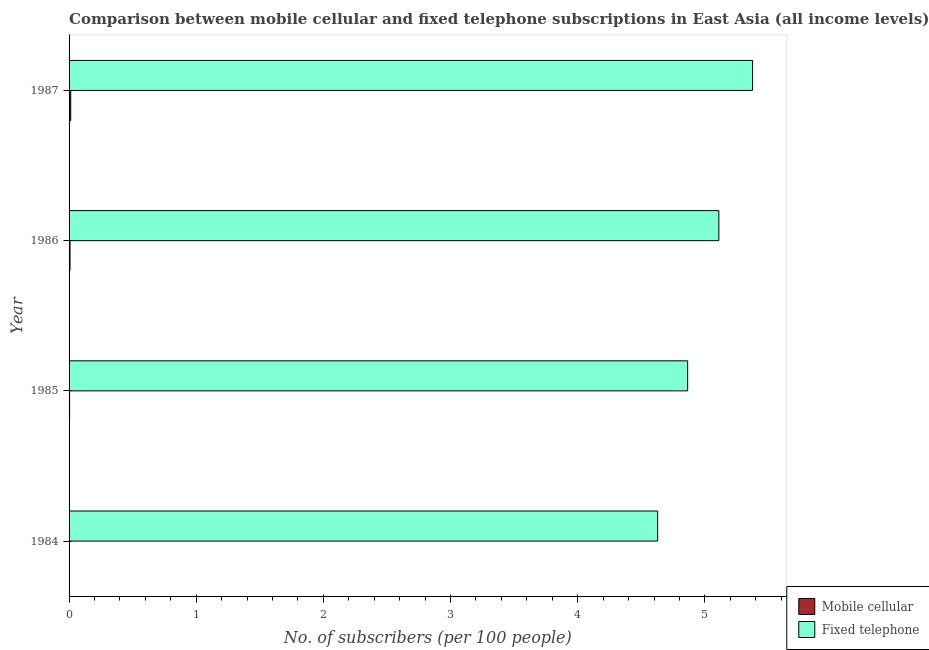How many groups of bars are there?
Offer a very short reply. 4. Are the number of bars per tick equal to the number of legend labels?
Make the answer very short. Yes. Are the number of bars on each tick of the Y-axis equal?
Give a very brief answer. Yes. How many bars are there on the 2nd tick from the top?
Keep it short and to the point. 2. How many bars are there on the 4th tick from the bottom?
Offer a terse response. 2. What is the label of the 3rd group of bars from the top?
Provide a succinct answer. 1985. What is the number of fixed telephone subscribers in 1984?
Make the answer very short. 4.63. Across all years, what is the maximum number of mobile cellular subscribers?
Provide a succinct answer. 0.01. Across all years, what is the minimum number of mobile cellular subscribers?
Your response must be concise. 0. In which year was the number of fixed telephone subscribers maximum?
Provide a succinct answer. 1987. In which year was the number of fixed telephone subscribers minimum?
Your answer should be very brief. 1984. What is the total number of fixed telephone subscribers in the graph?
Offer a very short reply. 19.98. What is the difference between the number of mobile cellular subscribers in 1985 and that in 1987?
Your response must be concise. -0.01. What is the difference between the number of fixed telephone subscribers in 1984 and the number of mobile cellular subscribers in 1987?
Provide a succinct answer. 4.62. What is the average number of mobile cellular subscribers per year?
Give a very brief answer. 0.01. In the year 1984, what is the difference between the number of mobile cellular subscribers and number of fixed telephone subscribers?
Keep it short and to the point. -4.63. What is the ratio of the number of fixed telephone subscribers in 1985 to that in 1987?
Provide a succinct answer. 0.91. What is the difference between the highest and the second highest number of mobile cellular subscribers?
Provide a short and direct response. 0.01. In how many years, is the number of mobile cellular subscribers greater than the average number of mobile cellular subscribers taken over all years?
Keep it short and to the point. 2. Is the sum of the number of fixed telephone subscribers in 1984 and 1985 greater than the maximum number of mobile cellular subscribers across all years?
Offer a terse response. Yes. What does the 1st bar from the top in 1987 represents?
Give a very brief answer. Fixed telephone. What does the 1st bar from the bottom in 1984 represents?
Your answer should be compact. Mobile cellular. How many bars are there?
Your response must be concise. 8. How many years are there in the graph?
Give a very brief answer. 4. What is the difference between two consecutive major ticks on the X-axis?
Provide a short and direct response. 1. Does the graph contain any zero values?
Your response must be concise. No. What is the title of the graph?
Provide a short and direct response. Comparison between mobile cellular and fixed telephone subscriptions in East Asia (all income levels). What is the label or title of the X-axis?
Your answer should be very brief. No. of subscribers (per 100 people). What is the No. of subscribers (per 100 people) of Mobile cellular in 1984?
Make the answer very short. 0. What is the No. of subscribers (per 100 people) of Fixed telephone in 1984?
Give a very brief answer. 4.63. What is the No. of subscribers (per 100 people) in Mobile cellular in 1985?
Keep it short and to the point. 0. What is the No. of subscribers (per 100 people) in Fixed telephone in 1985?
Your answer should be very brief. 4.86. What is the No. of subscribers (per 100 people) in Mobile cellular in 1986?
Your answer should be very brief. 0.01. What is the No. of subscribers (per 100 people) in Fixed telephone in 1986?
Ensure brevity in your answer.  5.11. What is the No. of subscribers (per 100 people) of Mobile cellular in 1987?
Give a very brief answer. 0.01. What is the No. of subscribers (per 100 people) in Fixed telephone in 1987?
Provide a short and direct response. 5.38. Across all years, what is the maximum No. of subscribers (per 100 people) in Mobile cellular?
Your answer should be compact. 0.01. Across all years, what is the maximum No. of subscribers (per 100 people) in Fixed telephone?
Give a very brief answer. 5.38. Across all years, what is the minimum No. of subscribers (per 100 people) in Mobile cellular?
Your answer should be very brief. 0. Across all years, what is the minimum No. of subscribers (per 100 people) in Fixed telephone?
Provide a succinct answer. 4.63. What is the total No. of subscribers (per 100 people) of Mobile cellular in the graph?
Make the answer very short. 0.03. What is the total No. of subscribers (per 100 people) of Fixed telephone in the graph?
Your answer should be compact. 19.98. What is the difference between the No. of subscribers (per 100 people) of Mobile cellular in 1984 and that in 1985?
Provide a succinct answer. -0. What is the difference between the No. of subscribers (per 100 people) of Fixed telephone in 1984 and that in 1985?
Make the answer very short. -0.24. What is the difference between the No. of subscribers (per 100 people) of Mobile cellular in 1984 and that in 1986?
Give a very brief answer. -0. What is the difference between the No. of subscribers (per 100 people) in Fixed telephone in 1984 and that in 1986?
Ensure brevity in your answer.  -0.48. What is the difference between the No. of subscribers (per 100 people) of Mobile cellular in 1984 and that in 1987?
Keep it short and to the point. -0.01. What is the difference between the No. of subscribers (per 100 people) in Fixed telephone in 1984 and that in 1987?
Offer a very short reply. -0.75. What is the difference between the No. of subscribers (per 100 people) of Mobile cellular in 1985 and that in 1986?
Ensure brevity in your answer.  -0. What is the difference between the No. of subscribers (per 100 people) in Fixed telephone in 1985 and that in 1986?
Give a very brief answer. -0.25. What is the difference between the No. of subscribers (per 100 people) in Mobile cellular in 1985 and that in 1987?
Your response must be concise. -0.01. What is the difference between the No. of subscribers (per 100 people) of Fixed telephone in 1985 and that in 1987?
Your response must be concise. -0.51. What is the difference between the No. of subscribers (per 100 people) in Mobile cellular in 1986 and that in 1987?
Provide a short and direct response. -0.01. What is the difference between the No. of subscribers (per 100 people) of Fixed telephone in 1986 and that in 1987?
Provide a short and direct response. -0.27. What is the difference between the No. of subscribers (per 100 people) of Mobile cellular in 1984 and the No. of subscribers (per 100 people) of Fixed telephone in 1985?
Make the answer very short. -4.86. What is the difference between the No. of subscribers (per 100 people) in Mobile cellular in 1984 and the No. of subscribers (per 100 people) in Fixed telephone in 1986?
Provide a succinct answer. -5.11. What is the difference between the No. of subscribers (per 100 people) in Mobile cellular in 1984 and the No. of subscribers (per 100 people) in Fixed telephone in 1987?
Your response must be concise. -5.37. What is the difference between the No. of subscribers (per 100 people) of Mobile cellular in 1985 and the No. of subscribers (per 100 people) of Fixed telephone in 1986?
Keep it short and to the point. -5.11. What is the difference between the No. of subscribers (per 100 people) of Mobile cellular in 1985 and the No. of subscribers (per 100 people) of Fixed telephone in 1987?
Keep it short and to the point. -5.37. What is the difference between the No. of subscribers (per 100 people) in Mobile cellular in 1986 and the No. of subscribers (per 100 people) in Fixed telephone in 1987?
Give a very brief answer. -5.37. What is the average No. of subscribers (per 100 people) of Mobile cellular per year?
Make the answer very short. 0.01. What is the average No. of subscribers (per 100 people) in Fixed telephone per year?
Keep it short and to the point. 4.99. In the year 1984, what is the difference between the No. of subscribers (per 100 people) in Mobile cellular and No. of subscribers (per 100 people) in Fixed telephone?
Make the answer very short. -4.63. In the year 1985, what is the difference between the No. of subscribers (per 100 people) of Mobile cellular and No. of subscribers (per 100 people) of Fixed telephone?
Your response must be concise. -4.86. In the year 1986, what is the difference between the No. of subscribers (per 100 people) in Mobile cellular and No. of subscribers (per 100 people) in Fixed telephone?
Your response must be concise. -5.1. In the year 1987, what is the difference between the No. of subscribers (per 100 people) in Mobile cellular and No. of subscribers (per 100 people) in Fixed telephone?
Keep it short and to the point. -5.36. What is the ratio of the No. of subscribers (per 100 people) of Mobile cellular in 1984 to that in 1985?
Your response must be concise. 0.64. What is the ratio of the No. of subscribers (per 100 people) in Fixed telephone in 1984 to that in 1985?
Ensure brevity in your answer.  0.95. What is the ratio of the No. of subscribers (per 100 people) in Mobile cellular in 1984 to that in 1986?
Ensure brevity in your answer.  0.36. What is the ratio of the No. of subscribers (per 100 people) in Fixed telephone in 1984 to that in 1986?
Keep it short and to the point. 0.91. What is the ratio of the No. of subscribers (per 100 people) of Mobile cellular in 1984 to that in 1987?
Your response must be concise. 0.21. What is the ratio of the No. of subscribers (per 100 people) in Fixed telephone in 1984 to that in 1987?
Make the answer very short. 0.86. What is the ratio of the No. of subscribers (per 100 people) in Mobile cellular in 1985 to that in 1986?
Your response must be concise. 0.56. What is the ratio of the No. of subscribers (per 100 people) in Fixed telephone in 1985 to that in 1986?
Your answer should be very brief. 0.95. What is the ratio of the No. of subscribers (per 100 people) of Mobile cellular in 1985 to that in 1987?
Your answer should be very brief. 0.32. What is the ratio of the No. of subscribers (per 100 people) of Fixed telephone in 1985 to that in 1987?
Your answer should be very brief. 0.91. What is the ratio of the No. of subscribers (per 100 people) of Mobile cellular in 1986 to that in 1987?
Offer a terse response. 0.58. What is the ratio of the No. of subscribers (per 100 people) in Fixed telephone in 1986 to that in 1987?
Provide a succinct answer. 0.95. What is the difference between the highest and the second highest No. of subscribers (per 100 people) of Mobile cellular?
Offer a very short reply. 0.01. What is the difference between the highest and the second highest No. of subscribers (per 100 people) of Fixed telephone?
Give a very brief answer. 0.27. What is the difference between the highest and the lowest No. of subscribers (per 100 people) in Mobile cellular?
Your response must be concise. 0.01. What is the difference between the highest and the lowest No. of subscribers (per 100 people) of Fixed telephone?
Keep it short and to the point. 0.75. 